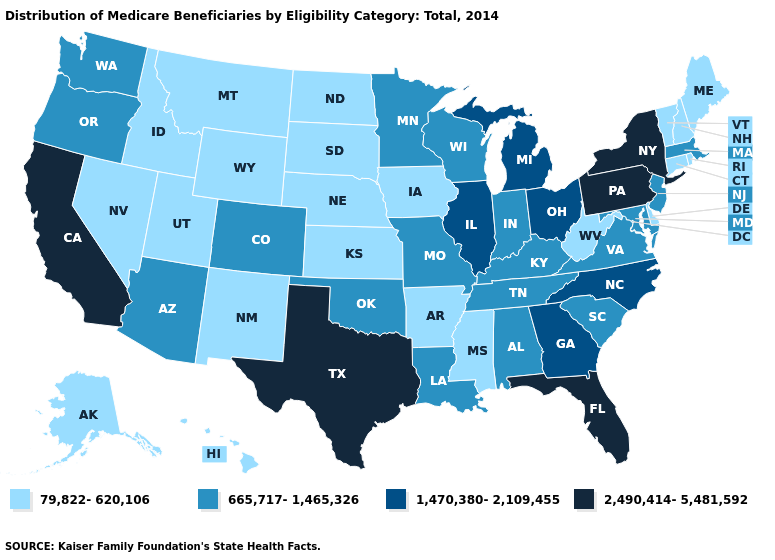What is the lowest value in states that border Missouri?
Be succinct. 79,822-620,106. Name the states that have a value in the range 1,470,380-2,109,455?
Concise answer only. Georgia, Illinois, Michigan, North Carolina, Ohio. Does Michigan have the lowest value in the USA?
Give a very brief answer. No. Does the map have missing data?
Give a very brief answer. No. What is the value of Utah?
Short answer required. 79,822-620,106. What is the highest value in the USA?
Give a very brief answer. 2,490,414-5,481,592. Name the states that have a value in the range 665,717-1,465,326?
Concise answer only. Alabama, Arizona, Colorado, Indiana, Kentucky, Louisiana, Maryland, Massachusetts, Minnesota, Missouri, New Jersey, Oklahoma, Oregon, South Carolina, Tennessee, Virginia, Washington, Wisconsin. Which states have the highest value in the USA?
Short answer required. California, Florida, New York, Pennsylvania, Texas. Name the states that have a value in the range 2,490,414-5,481,592?
Give a very brief answer. California, Florida, New York, Pennsylvania, Texas. What is the value of Wyoming?
Keep it brief. 79,822-620,106. What is the value of North Carolina?
Short answer required. 1,470,380-2,109,455. What is the value of Louisiana?
Short answer required. 665,717-1,465,326. Which states have the lowest value in the USA?
Be succinct. Alaska, Arkansas, Connecticut, Delaware, Hawaii, Idaho, Iowa, Kansas, Maine, Mississippi, Montana, Nebraska, Nevada, New Hampshire, New Mexico, North Dakota, Rhode Island, South Dakota, Utah, Vermont, West Virginia, Wyoming. What is the value of Minnesota?
Keep it brief. 665,717-1,465,326. How many symbols are there in the legend?
Keep it brief. 4. 